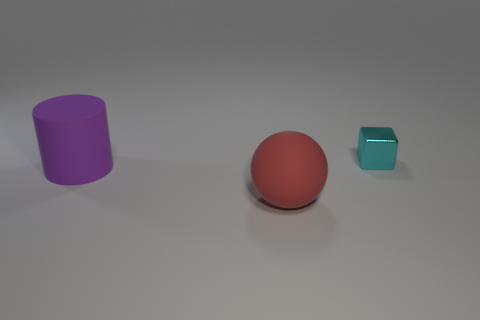Add 1 purple cylinders. How many objects exist? 4 Subtract all cylinders. How many objects are left? 2 Subtract all big yellow cylinders. Subtract all large red matte balls. How many objects are left? 2 Add 1 big purple objects. How many big purple objects are left? 2 Add 3 large purple objects. How many large purple objects exist? 4 Subtract 0 yellow cylinders. How many objects are left? 3 